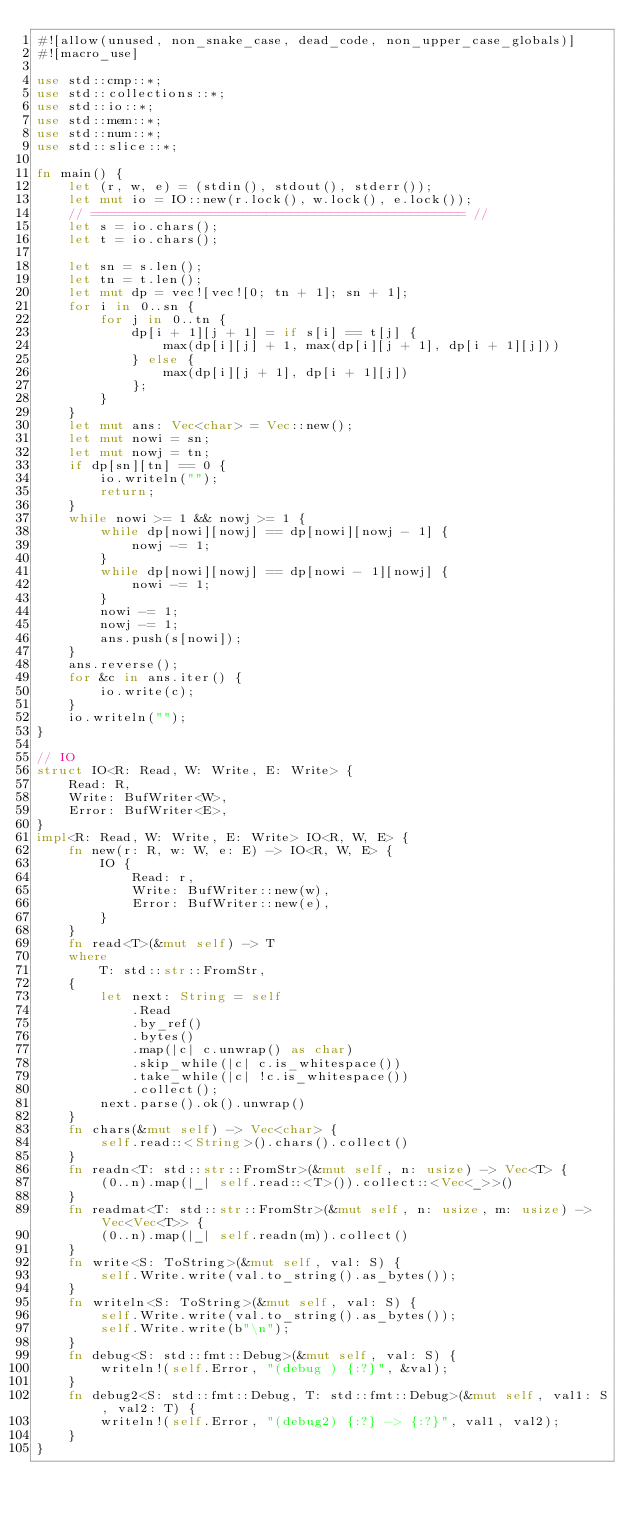<code> <loc_0><loc_0><loc_500><loc_500><_Rust_>#![allow(unused, non_snake_case, dead_code, non_upper_case_globals)]
#![macro_use]

use std::cmp::*;
use std::collections::*;
use std::io::*;
use std::mem::*;
use std::num::*;
use std::slice::*;

fn main() {
    let (r, w, e) = (stdin(), stdout(), stderr());
    let mut io = IO::new(r.lock(), w.lock(), e.lock());
    // =============================================== //
    let s = io.chars();
    let t = io.chars();

    let sn = s.len();
    let tn = t.len();
    let mut dp = vec![vec![0; tn + 1]; sn + 1];
    for i in 0..sn {
        for j in 0..tn {
            dp[i + 1][j + 1] = if s[i] == t[j] {
                max(dp[i][j] + 1, max(dp[i][j + 1], dp[i + 1][j]))
            } else {
                max(dp[i][j + 1], dp[i + 1][j])
            };
        }
    }
    let mut ans: Vec<char> = Vec::new();
    let mut nowi = sn;
    let mut nowj = tn;
    if dp[sn][tn] == 0 {
        io.writeln("");
        return;
    }
    while nowi >= 1 && nowj >= 1 {
        while dp[nowi][nowj] == dp[nowi][nowj - 1] {
            nowj -= 1;
        }
        while dp[nowi][nowj] == dp[nowi - 1][nowj] {
            nowi -= 1;
        }
        nowi -= 1;
        nowj -= 1;
        ans.push(s[nowi]);
    }
    ans.reverse();
    for &c in ans.iter() {
        io.write(c);
    }
    io.writeln("");
}

// IO
struct IO<R: Read, W: Write, E: Write> {
    Read: R,
    Write: BufWriter<W>,
    Error: BufWriter<E>,
}
impl<R: Read, W: Write, E: Write> IO<R, W, E> {
    fn new(r: R, w: W, e: E) -> IO<R, W, E> {
        IO {
            Read: r,
            Write: BufWriter::new(w),
            Error: BufWriter::new(e),
        }
    }
    fn read<T>(&mut self) -> T
    where
        T: std::str::FromStr,
    {
        let next: String = self
            .Read
            .by_ref()
            .bytes()
            .map(|c| c.unwrap() as char)
            .skip_while(|c| c.is_whitespace())
            .take_while(|c| !c.is_whitespace())
            .collect();
        next.parse().ok().unwrap()
    }
    fn chars(&mut self) -> Vec<char> {
        self.read::<String>().chars().collect()
    }
    fn readn<T: std::str::FromStr>(&mut self, n: usize) -> Vec<T> {
        (0..n).map(|_| self.read::<T>()).collect::<Vec<_>>()
    }
    fn readmat<T: std::str::FromStr>(&mut self, n: usize, m: usize) -> Vec<Vec<T>> {
        (0..n).map(|_| self.readn(m)).collect()
    }
    fn write<S: ToString>(&mut self, val: S) {
        self.Write.write(val.to_string().as_bytes());
    }
    fn writeln<S: ToString>(&mut self, val: S) {
        self.Write.write(val.to_string().as_bytes());
        self.Write.write(b"\n");
    }
    fn debug<S: std::fmt::Debug>(&mut self, val: S) {
        writeln!(self.Error, "(debug ) {:?}", &val);
    }
    fn debug2<S: std::fmt::Debug, T: std::fmt::Debug>(&mut self, val1: S, val2: T) {
        writeln!(self.Error, "(debug2) {:?} -> {:?}", val1, val2);
    }
}
</code> 